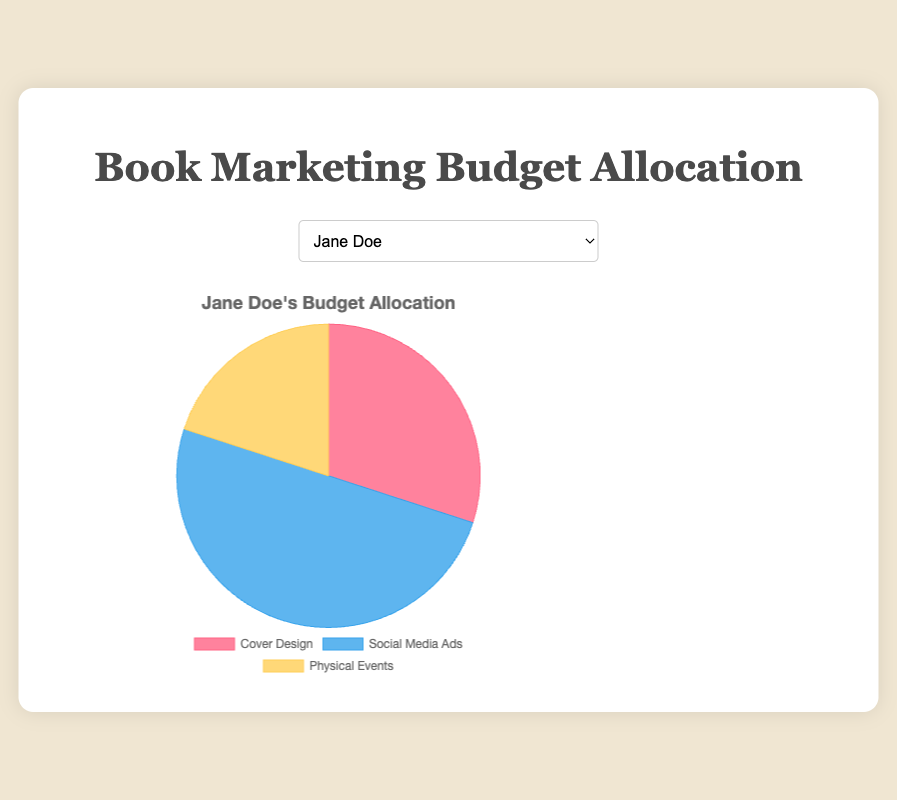What's the percentage allocation for cover design for John Smith? Look at John Smith's pie chart and identify the segment labeled "Cover Design." It shows 40%.
Answer: 40% Which author allocates the highest percentage of their budget to social media ads? Compare the social media ads allocation for all authors. Emily Clark allocates the highest at 55%.
Answer: Emily Clark What is the total budget percentage allocated to physical events across all authors? Each author allocates 20% to physical events. Summing these up: 20% * 5 authors = 100%.
Answer: 100% How much more does Jane Doe allocate to social media ads compared to Emily Clark? Jane Doe allocates 50%, and Emily Clark allocates 55% to social media ads. Subtracting these: 55% - 50% = 5%.
Answer: 5% If you combine the cover design and physical events budget for Michael Brown, what percentage does it represent? Michael Brown allocates 35% to cover design and 20% to physical events. Adding these: 35% + 20% = 55%.
Answer: 55% Who allocates the lowest percentage to cover design? Comparing the cover design percentages, Emily Clark allocates the lowest at 25%.
Answer: Emily Clark What is the difference in budget allocation for social media ads between Jane Doe and Sarah Johnson? Jane Doe allocates 50% and Sarah Johnson allocates 35%. Subtracting these: 50% - 35% = 15%.
Answer: 15% Among all authors, who has the most balanced budget allocation among the three categories? Among all authors, look for the smallest variation between categories. John Smith allocates 40% to cover design and social media ads, and 20% to physical events, showing the most balance.
Answer: John Smith How does Michael Brown’s allocation to physical events compare to his allocation to cover design and social media ads combined? Michael Brown allocates 20% to physical events and 35% to cover design, and 45% to social media ads combined. 35% + 45% = 80%. So, 80% - 20% = 60% more.
Answer: 60% more What's the average percentage allocation for cover design across all authors? Add each author’s cover design percentages and divide by the number of authors: (30% + 40% + 25% + 35% + 45%) / 5 = 35%.
Answer: 35% 